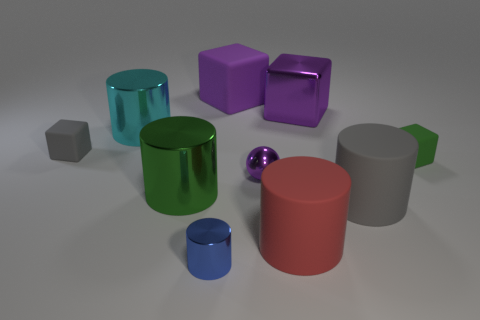What can you infer about the texture of the objects? The objects exhibit a range of textures. For example, the green cylinders have a smooth, shiny surface, indicative of a sleek texture. In contrast, the tiny grey cube has a dull surface, suggesting a rougher texture.  How many objects in the image have a cylindrical shape? There are three objects in the image with a cylindrical shape: the large green cylinder, the small blue cylinder, and the large grey cylinder. 